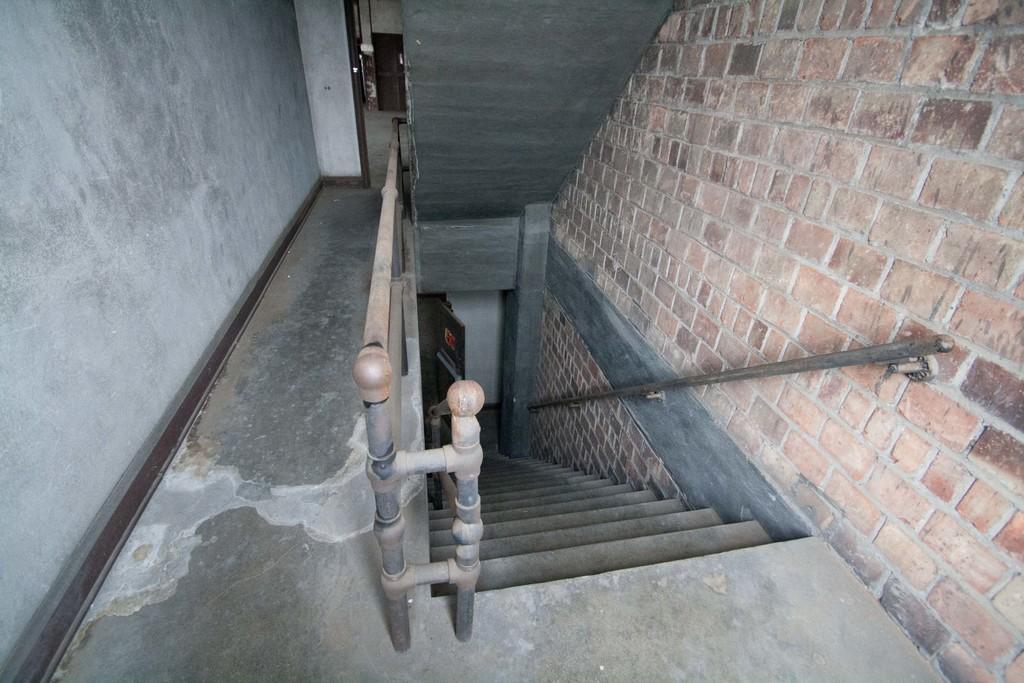How would you summarize this image in a sentence or two? This is an inner view of a building. In this image we can see the downstairs with a fence and a wall. 